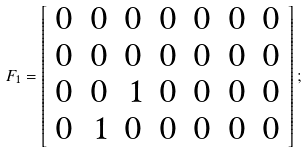Convert formula to latex. <formula><loc_0><loc_0><loc_500><loc_500>F _ { 1 } = \left [ \begin{array} { r r r r r r r r } 0 & 0 & 0 & 0 & 0 & 0 & 0 \\ 0 & 0 & 0 & 0 & 0 & 0 & 0 \\ 0 & 0 & 1 & 0 & 0 & 0 & 0 \\ 0 & 1 & 0 & 0 & 0 & 0 & 0 \\ \end{array} \right ] ;</formula> 